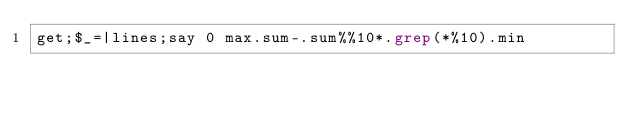Convert code to text. <code><loc_0><loc_0><loc_500><loc_500><_Perl_>get;$_=|lines;say 0 max.sum-.sum%%10*.grep(*%10).min</code> 